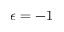Convert formula to latex. <formula><loc_0><loc_0><loc_500><loc_500>\epsilon = - 1</formula> 